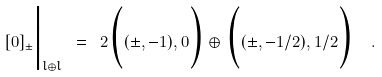Convert formula to latex. <formula><loc_0><loc_0><loc_500><loc_500>[ 0 ] _ { \pm } \Big | _ { \sl l \oplus \sl l } \ = \ 2 \Big ( ( \pm , - 1 ) , 0 \Big ) \oplus \Big ( ( \pm , - 1 / 2 ) , 1 / 2 \Big ) \ \ .</formula> 